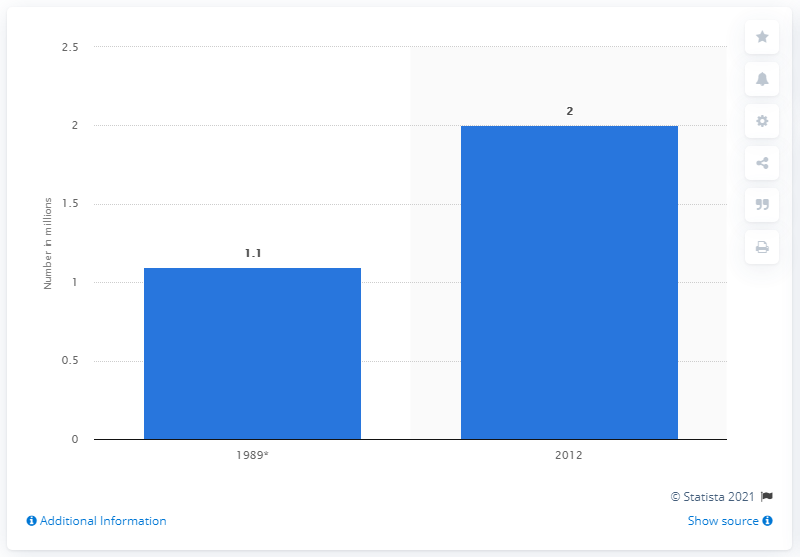Draw attention to some important aspects in this diagram. In 1989, the number of stay-at-home fathers in the United States was 1.1 million. In 2012, the number of stay-at-home fathers was 2. 